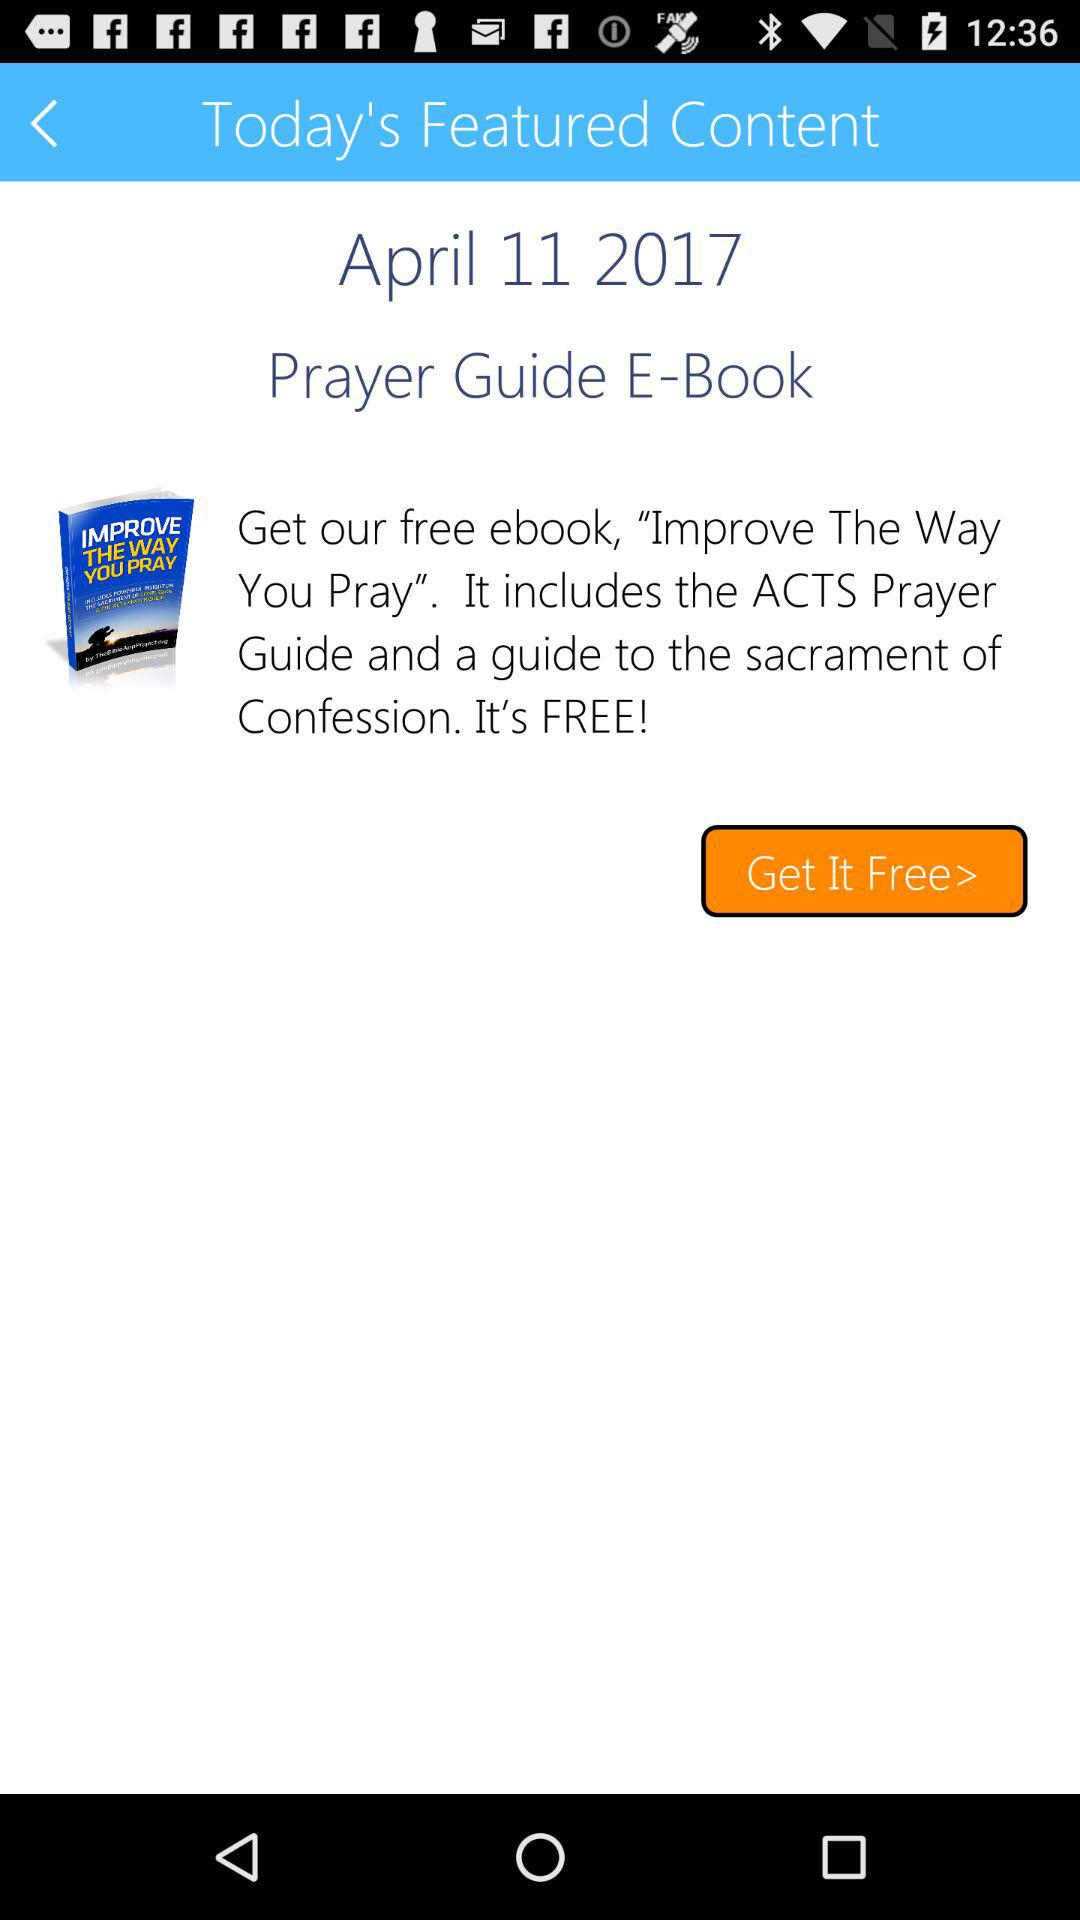What is the name of the ebook? The name of the ebook is "Improve The Way You Pray". 